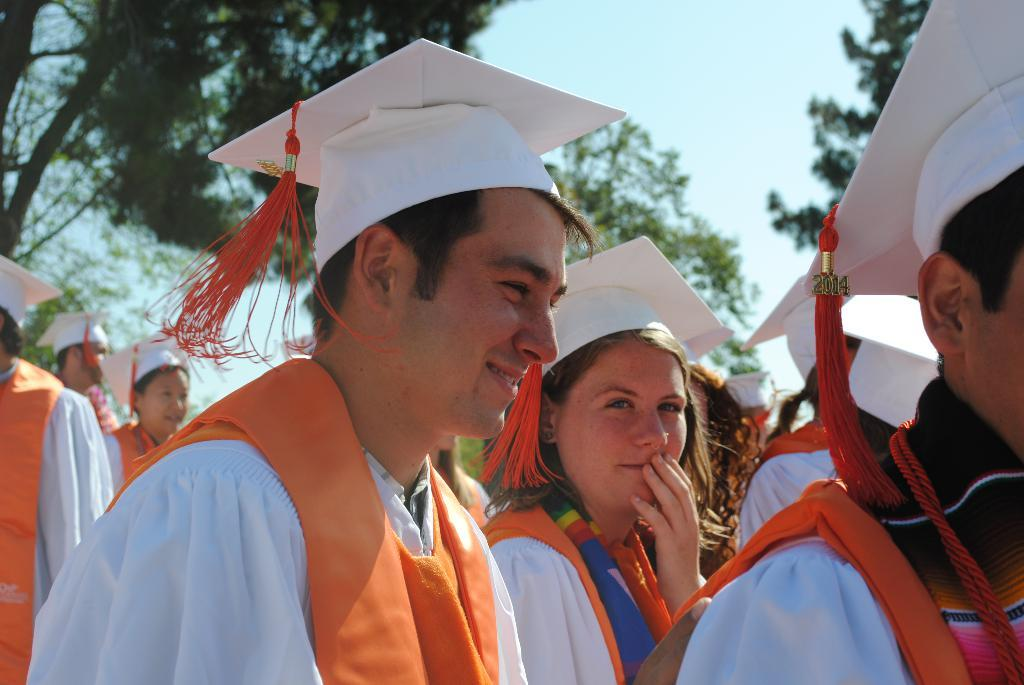What is the main subject of the image? The main subject of the image is a group of people. What are the people wearing in the image? The people are wearing white and orange combination dresses and white color hats. What can be seen in the top left corner of the image? There are trees visible in the top left corner of the image. Can you hear the people in the image laughing? The image is a still picture, so it does not capture any sounds, including laughter. What type of bait is being used by the people in the image? There is no indication in the image that the people are using any bait, as they are wearing dresses and hats, not engaging in any fishing or hunting activities. 